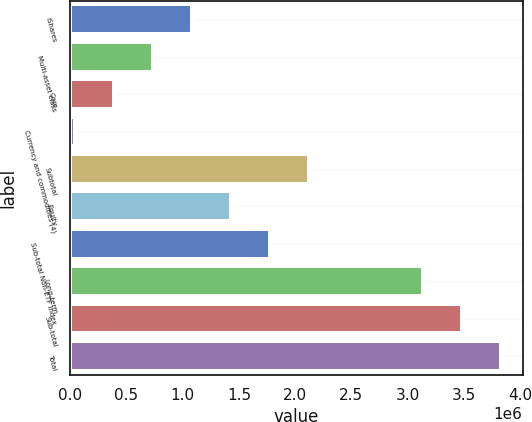Convert chart to OTSL. <chart><loc_0><loc_0><loc_500><loc_500><bar_chart><fcel>iShares<fcel>Multi-asset class<fcel>Core<fcel>Currency and commodities (4)<fcel>Subtotal<fcel>Equity<fcel>Sub-total Non-ETF Index<fcel>Long-term<fcel>Sub-total<fcel>Total<nl><fcel>1.08272e+06<fcel>735577<fcel>388439<fcel>41301<fcel>2.12413e+06<fcel>1.42985e+06<fcel>1.77699e+06<fcel>3.13795e+06<fcel>3.48508e+06<fcel>3.83222e+06<nl></chart> 